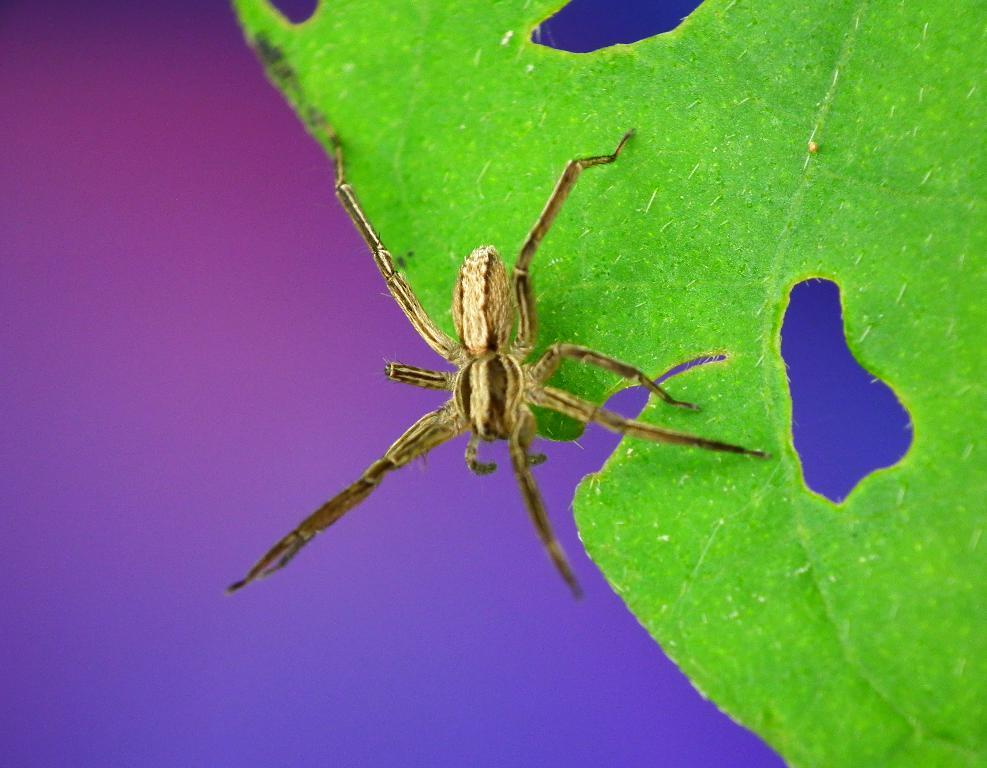What is the main subject of the image? There is a spider in the image. Where is the spider located? The spider is on a leaf. What colors can be seen in the background of the image? The background of the image has blue and pink colors. What type of haircut does the spider have in the image? There is no haircut present in the image, as spiders do not have hair. How many eyes can be seen on the spider in the image? The number of eyes on the spider cannot be determined from the image, as it is not possible to see the spider's eyes clearly. 